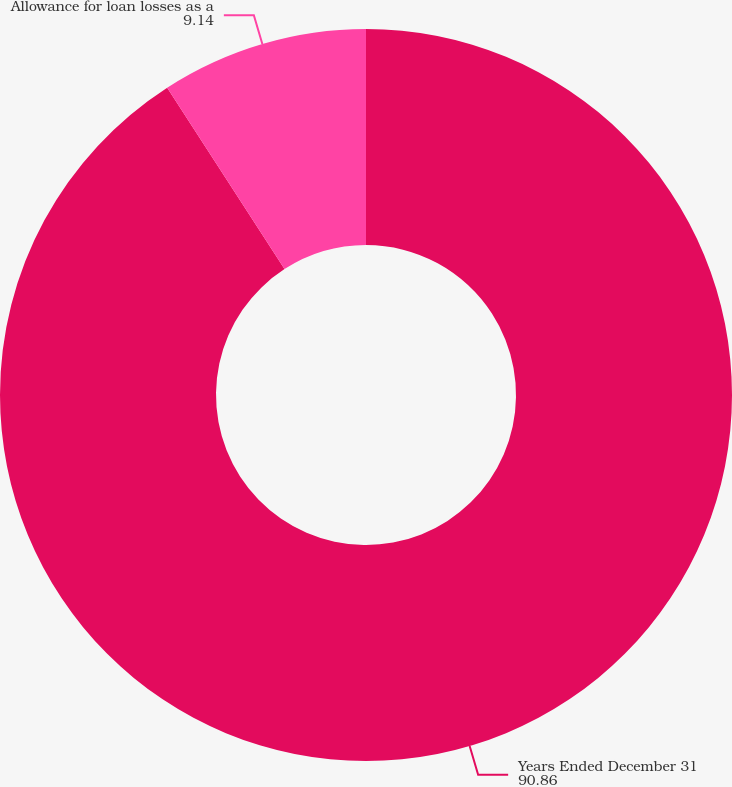<chart> <loc_0><loc_0><loc_500><loc_500><pie_chart><fcel>Years Ended December 31<fcel>Allowance for loan losses as a<nl><fcel>90.86%<fcel>9.14%<nl></chart> 